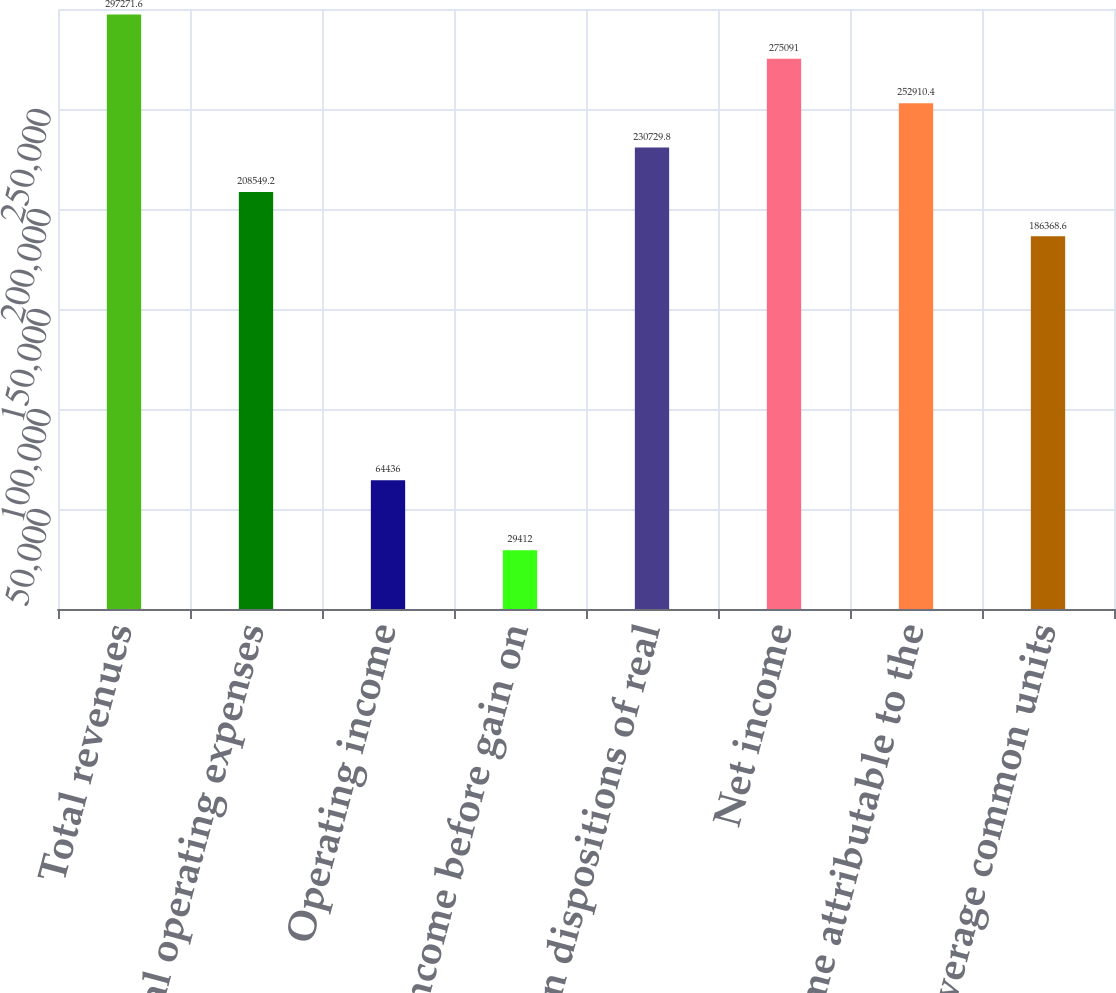Convert chart. <chart><loc_0><loc_0><loc_500><loc_500><bar_chart><fcel>Total revenues<fcel>Total operating expenses<fcel>Operating income<fcel>Income before gain on<fcel>Gain on dispositions of real<fcel>Net income<fcel>Net income attributable to the<fcel>Weighted average common units<nl><fcel>297272<fcel>208549<fcel>64436<fcel>29412<fcel>230730<fcel>275091<fcel>252910<fcel>186369<nl></chart> 